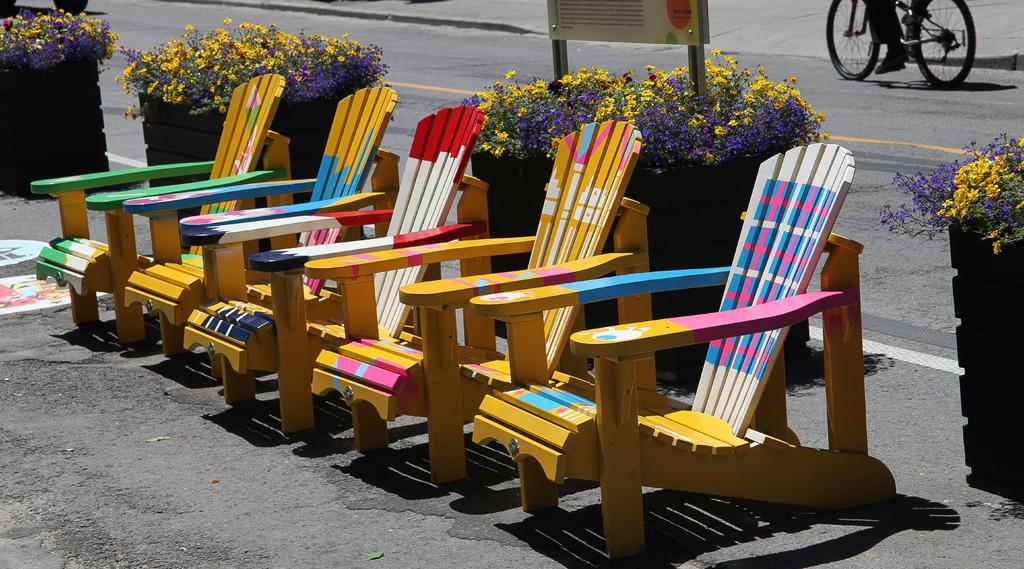How would you summarize this image in a sentence or two? In this image I can see some wooden chairs and the flowertots. There is also a person riding bicycle on the road. 